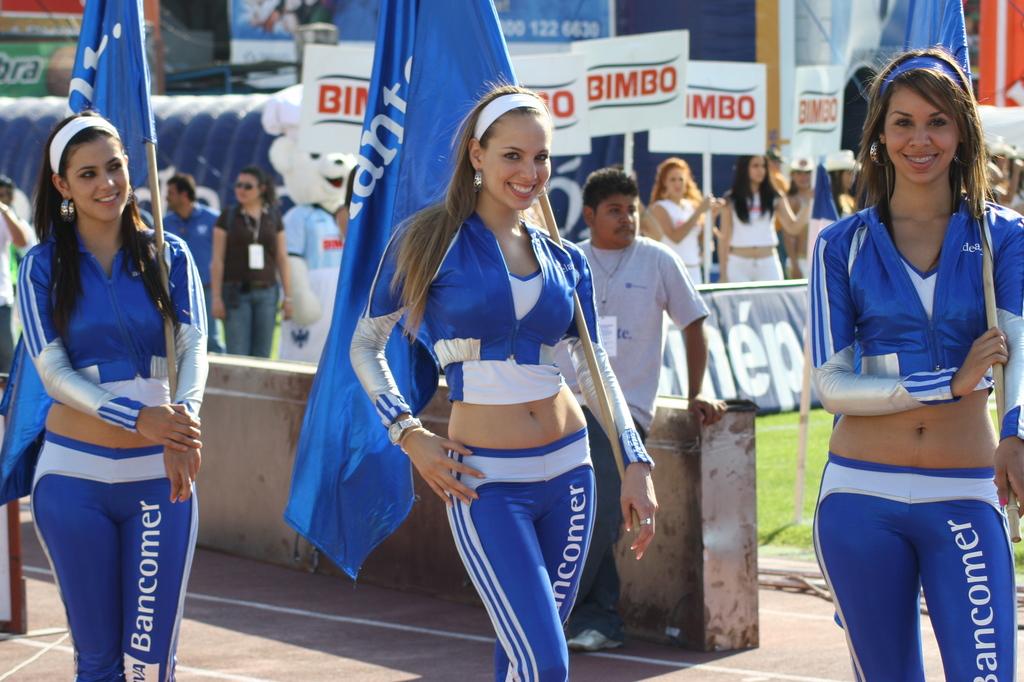What does their pant leg say?
Keep it short and to the point. Bancomer. What do the white signs say?
Your answer should be very brief. Bimbo. 